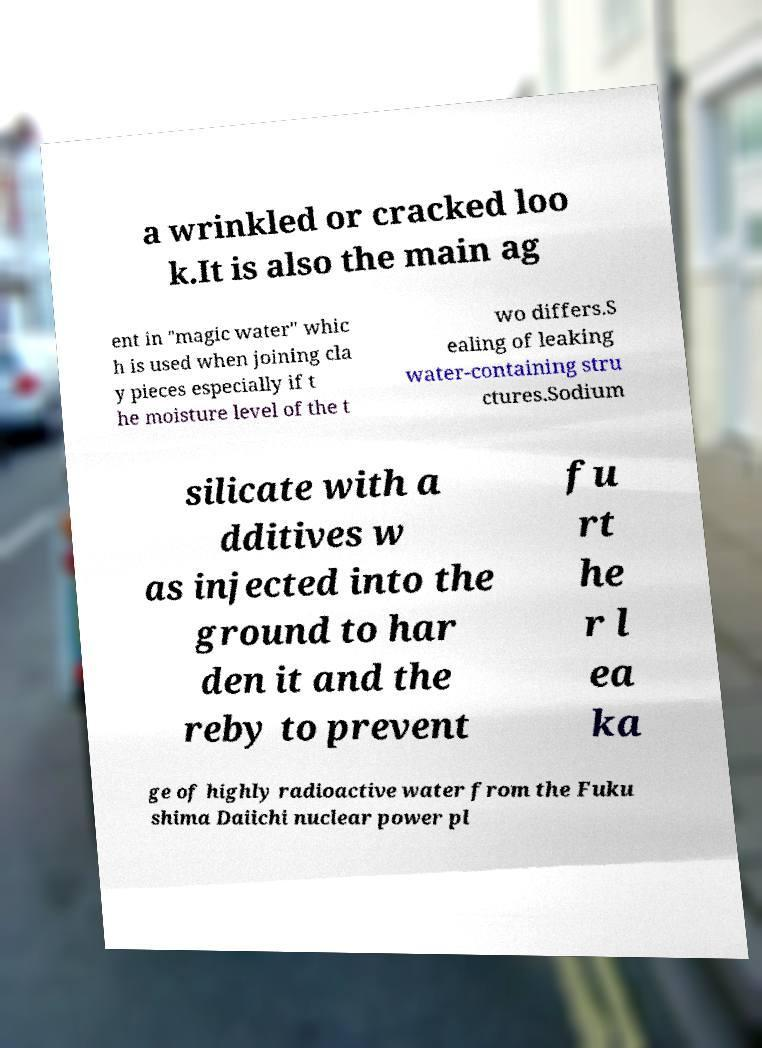What messages or text are displayed in this image? I need them in a readable, typed format. a wrinkled or cracked loo k.It is also the main ag ent in "magic water" whic h is used when joining cla y pieces especially if t he moisture level of the t wo differs.S ealing of leaking water-containing stru ctures.Sodium silicate with a dditives w as injected into the ground to har den it and the reby to prevent fu rt he r l ea ka ge of highly radioactive water from the Fuku shima Daiichi nuclear power pl 